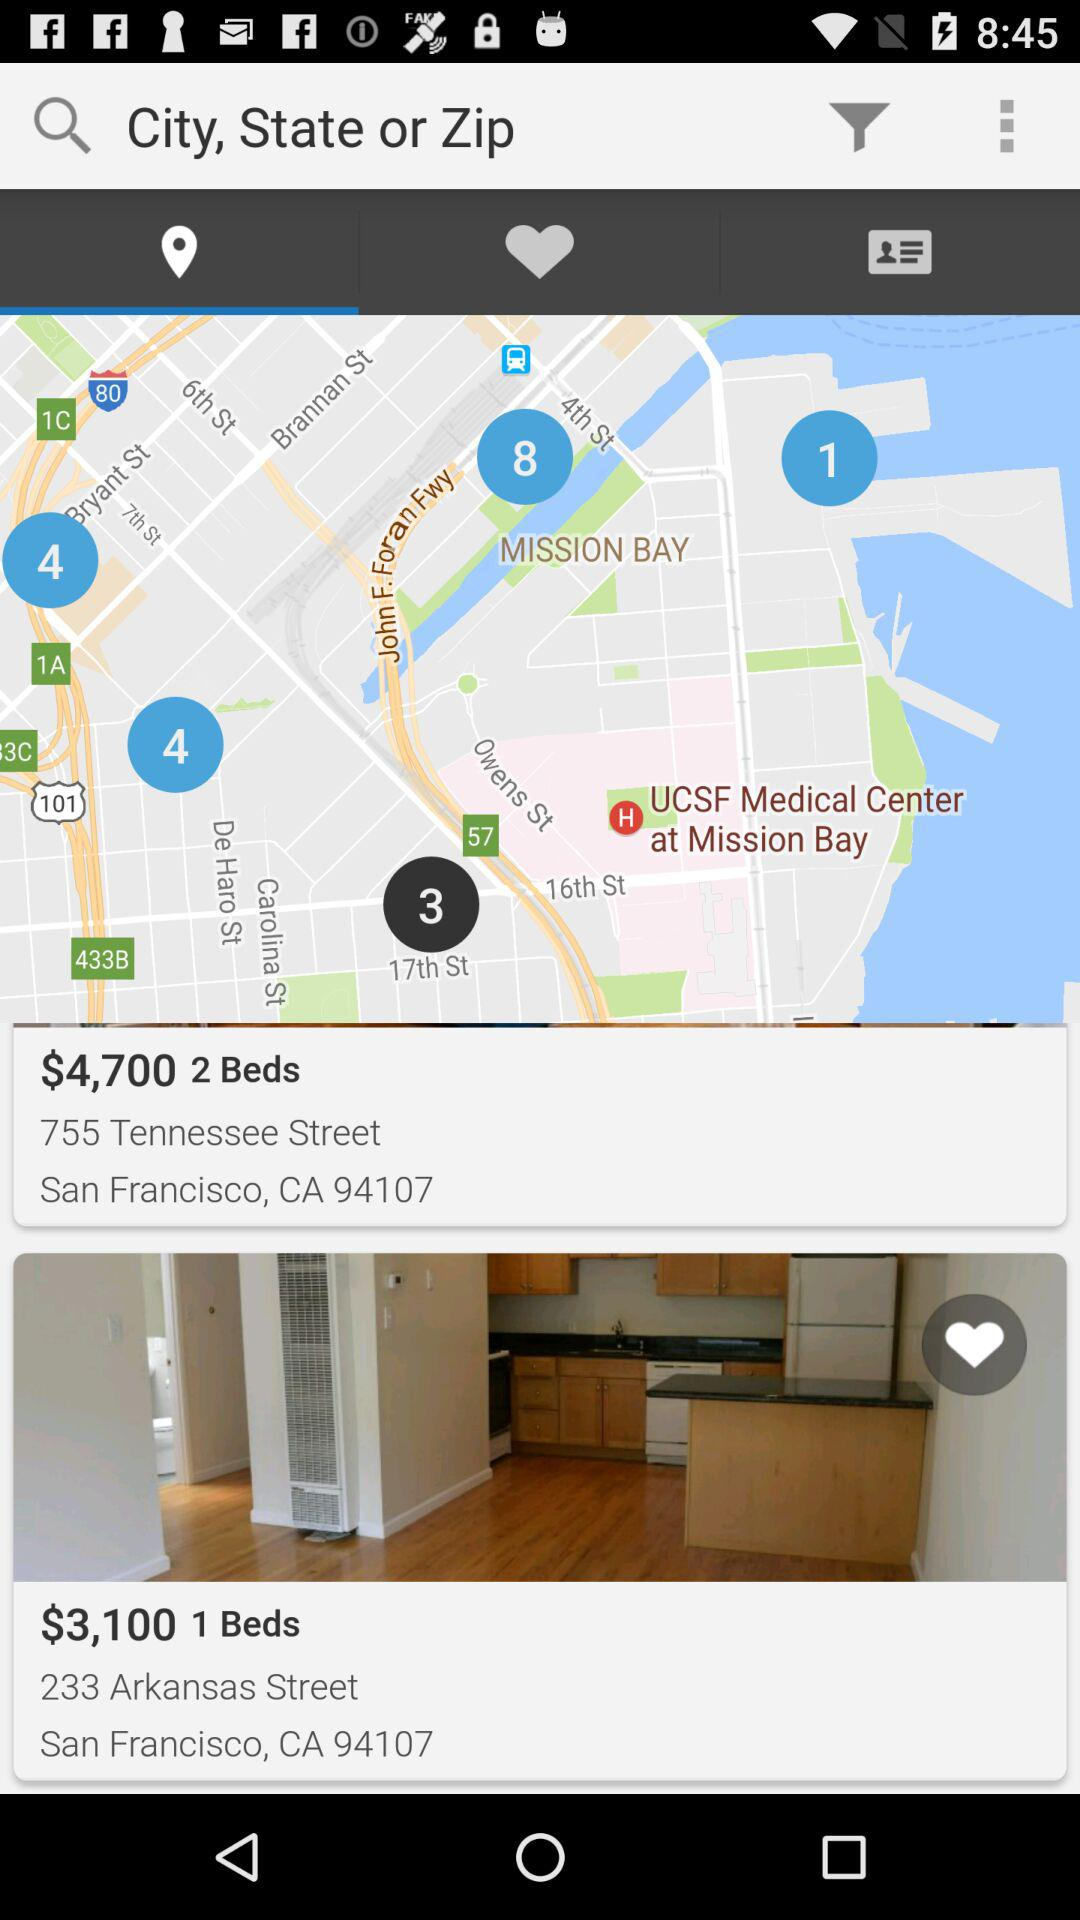What is the city of hotels? The city of hotels is San Francisco. 